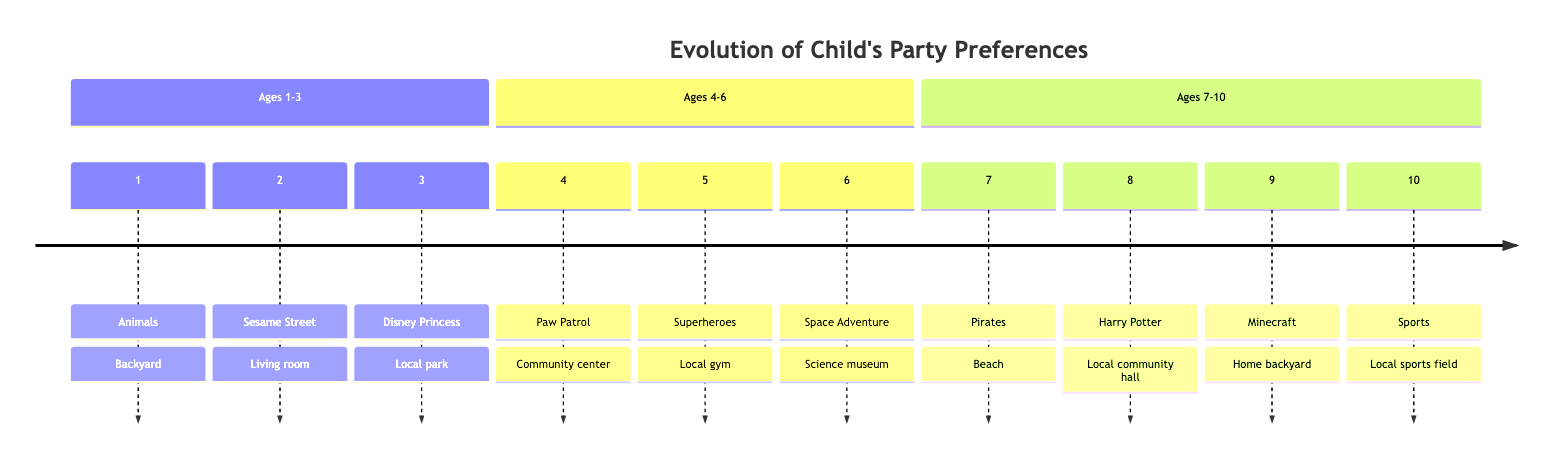What is the theme for age 3? The diagram shows that for age 3, the theme is "Disney Princess." This information can be found directly by locating the node corresponding to age 3 in the timeline.
Answer: Disney Princess How many activities are listed for the age 6 party? For age 6, there are two activities: "Rocket ship building" and "Solar system piñata." To determine this, I looked at the activities section for age 6 and counted them.
Answer: 2 What location is used for the age 5 party? The location for the age 5 party is "Local gym," which is directly labeled in the timeline next to the age 5 node.
Answer: Local gym What theme appears just before the age 7 celebration? Looking at the timeline, the theme for age 6 is "Space Adventure," which comes just before age 7. This can be determined by following the sequence of ages on the timeline.
Answer: Space Adventure Which age group has a party theme related to "Pirates"? The timeline indicates that the party theme related to "Pirates" is for age 7. By finding the node for age 7, I can confirm this theme.
Answer: 7 What activities are associated with the age 4 party? The age 4 party has the following activities: "Paw Patrol scavenger hunt" and "Obstacle course." These come from the activities listed directly next to age 4 in the timeline.
Answer: Paw Patrol scavenger hunt, Obstacle course How many guests are typically invited to the age 9 party? For the age 9 party, the guests are identified as "Fourth-grade friends" and "Cousins," totaling two groups of guests. I reviewed the guest section for age 9 to find this information.
Answer: 2 groups In which location is the age 8 party held? The location for the age 8 party is "Local community hall," which is specified in the timeline next to the age 8 theme.
Answer: Local community hall What theme involves building activities at age 6? The theme involving building activities at age 6 is "Space Adventure," which includes "Rocket ship building" as one of its activities. To answer this, I looked at the activities listed for age 6.
Answer: Space Adventure Which party has a sports theme and what age is it? The party with a sports theme is for age 10. The timeline lists the theme as "Sports" next to the age 10 node, allowing for this conclusion.
Answer: 10, Sports 